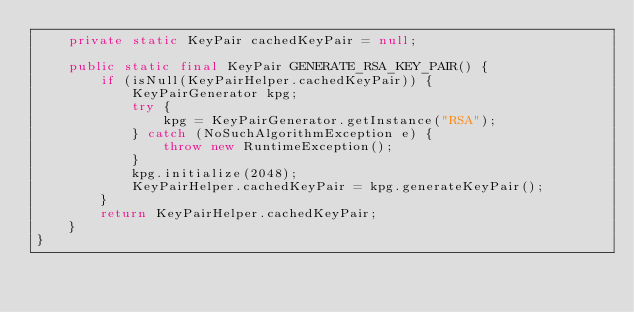Convert code to text. <code><loc_0><loc_0><loc_500><loc_500><_Java_>    private static KeyPair cachedKeyPair = null;

    public static final KeyPair GENERATE_RSA_KEY_PAIR() {
        if (isNull(KeyPairHelper.cachedKeyPair)) {
            KeyPairGenerator kpg;
            try {
                kpg = KeyPairGenerator.getInstance("RSA");
            } catch (NoSuchAlgorithmException e) {
                throw new RuntimeException();
            }
            kpg.initialize(2048);
            KeyPairHelper.cachedKeyPair = kpg.generateKeyPair();
        }
        return KeyPairHelper.cachedKeyPair;
    }
}
</code> 